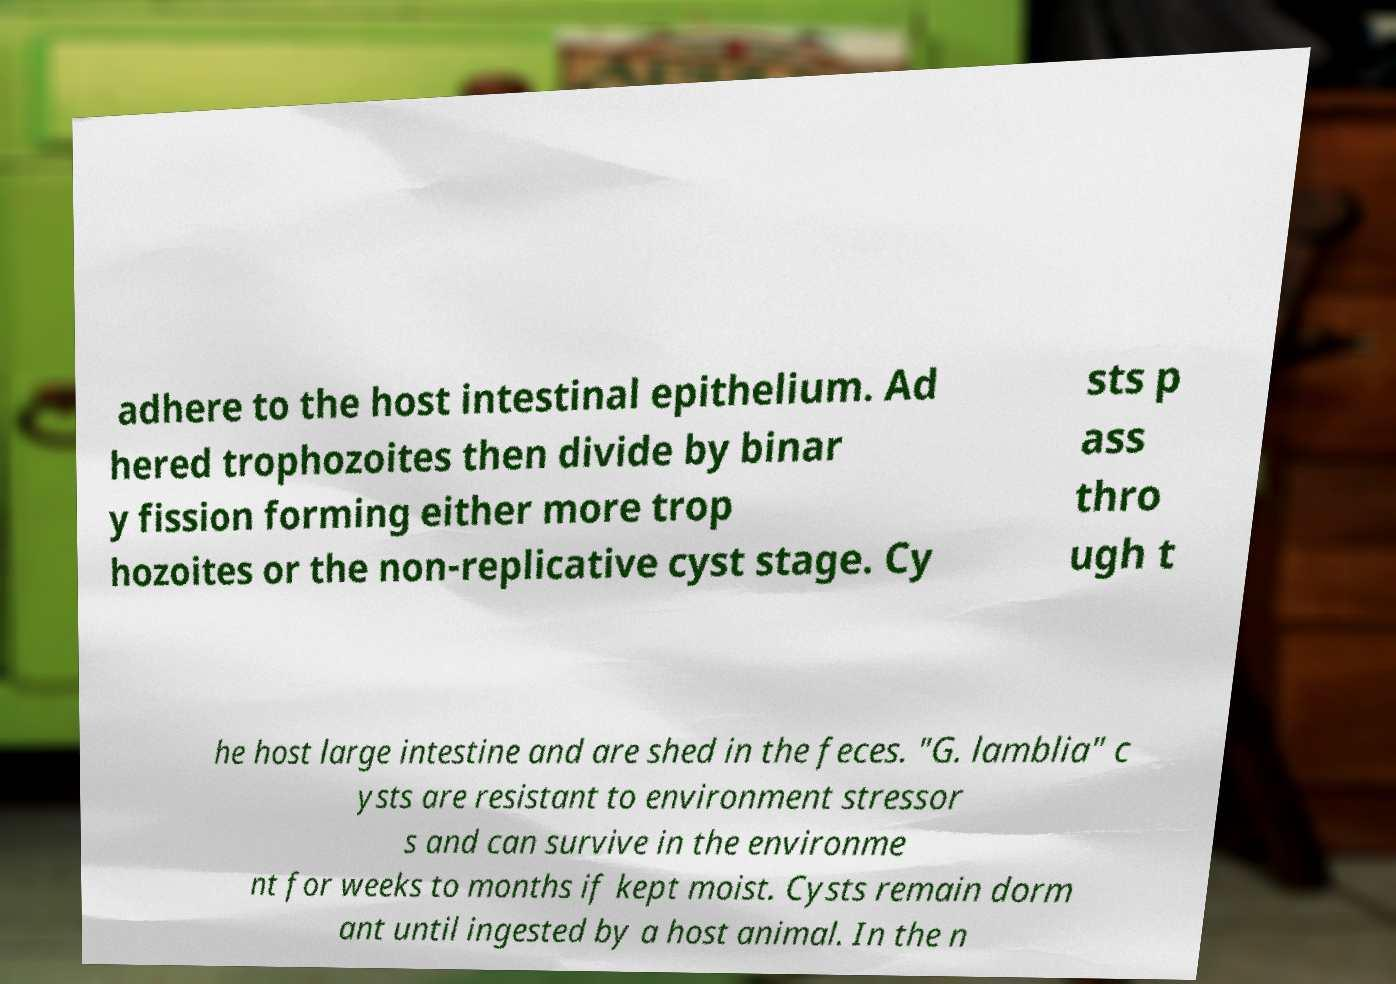For documentation purposes, I need the text within this image transcribed. Could you provide that? adhere to the host intestinal epithelium. Ad hered trophozoites then divide by binar y fission forming either more trop hozoites or the non-replicative cyst stage. Cy sts p ass thro ugh t he host large intestine and are shed in the feces. "G. lamblia" c ysts are resistant to environment stressor s and can survive in the environme nt for weeks to months if kept moist. Cysts remain dorm ant until ingested by a host animal. In the n 